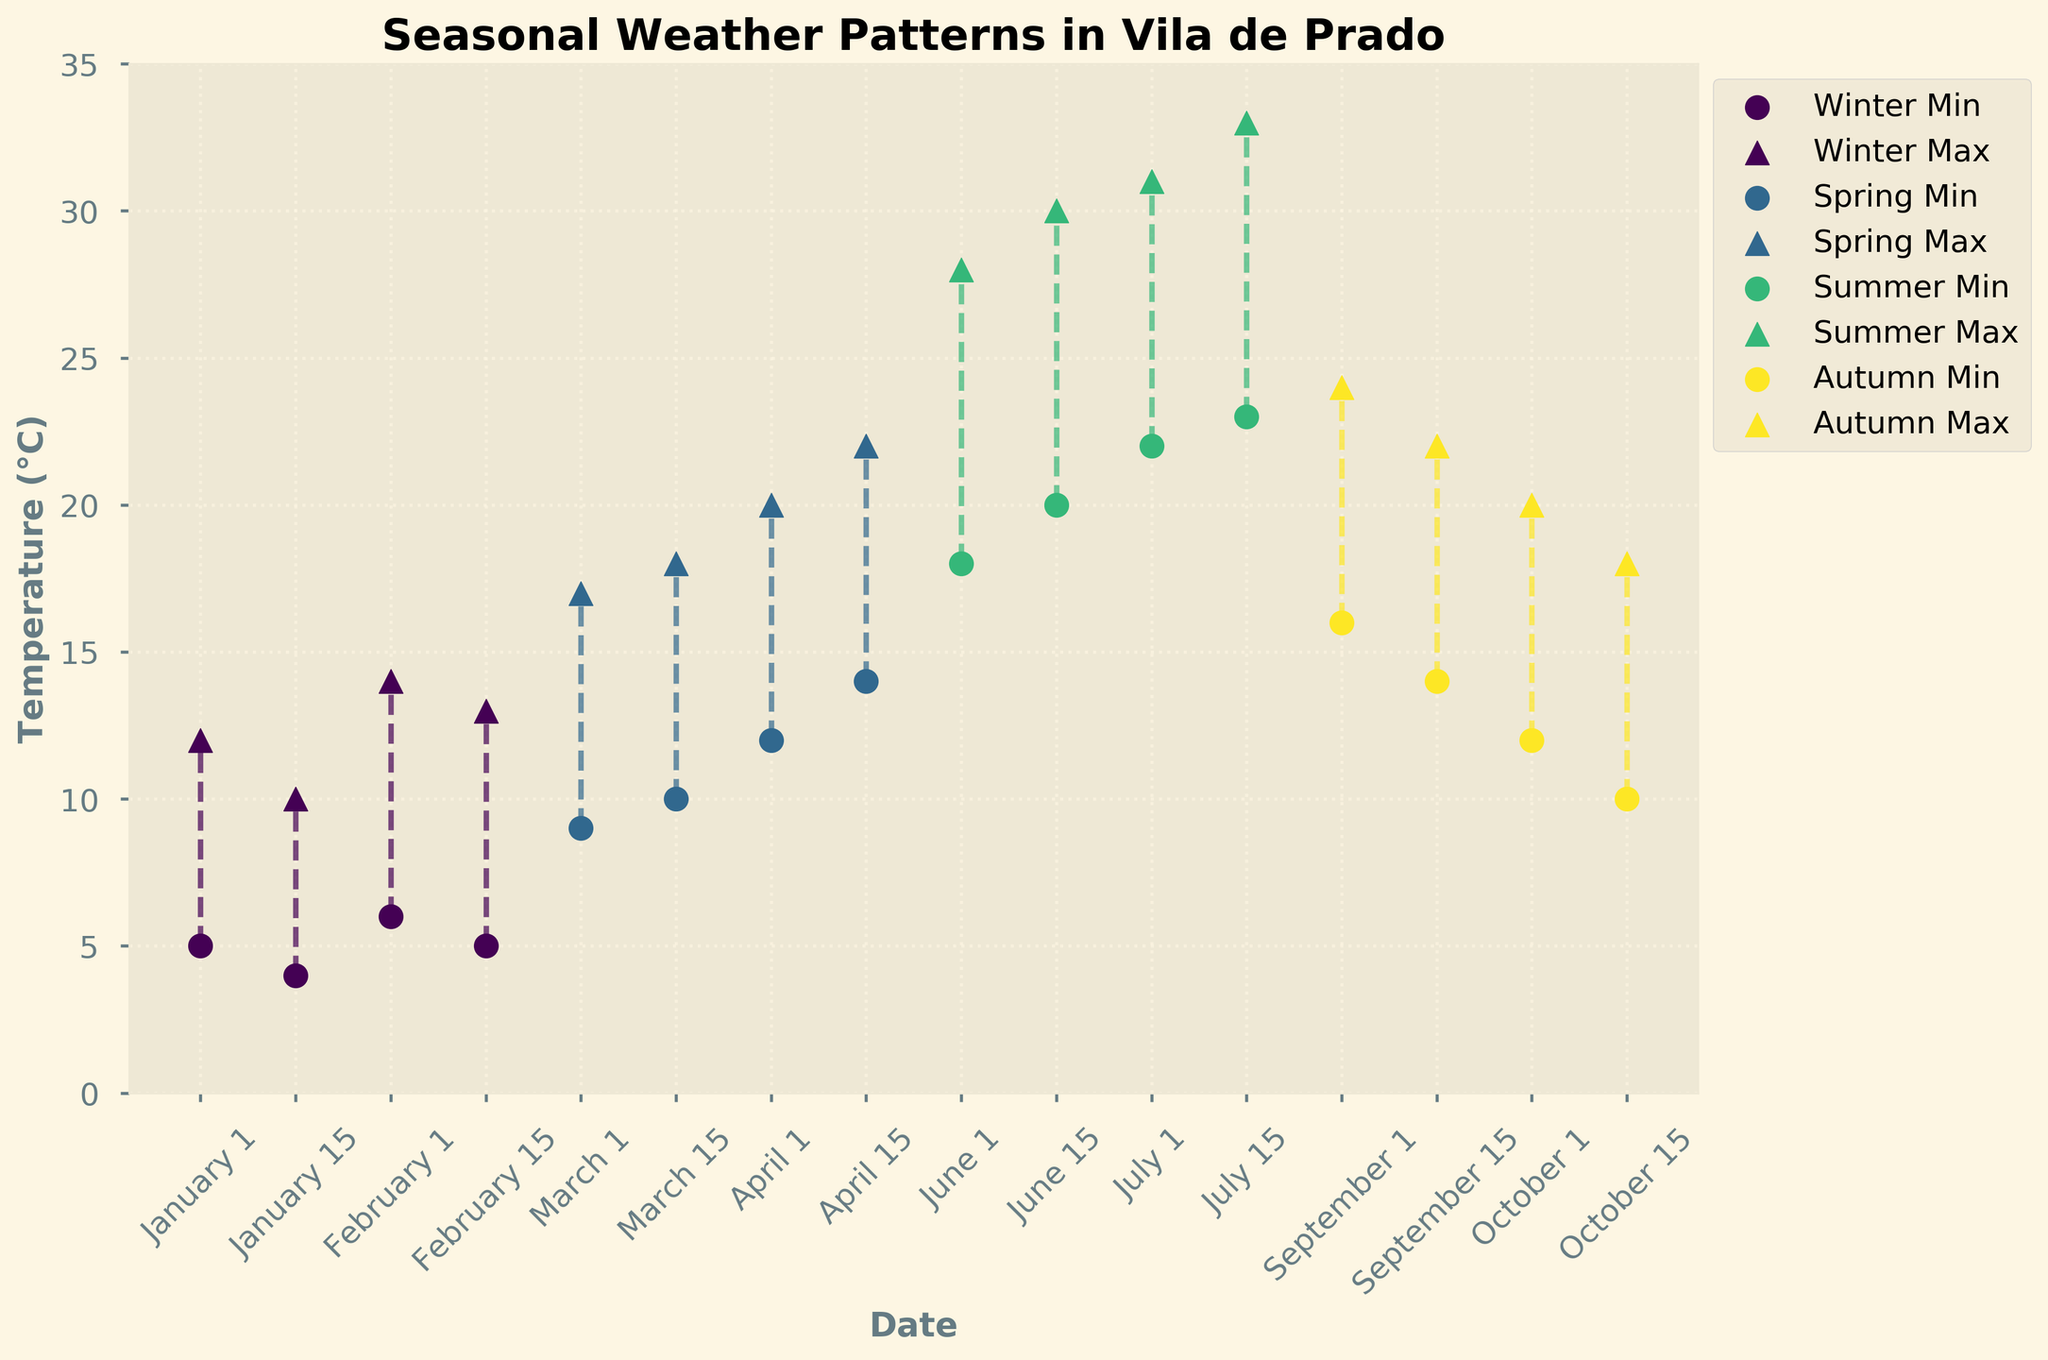What is the overall temperature range in February? Look at the min and max temperature values for February. The lowest min is 5°C, and the highest max is 14°C. The overall range is from 5°C to 14°C.
Answer: 5°C to 14°C Which season has the highest average maximum temperature? Calculate the average of maximum temperatures for each season and compare. Winter: (12+10+14+13)/4 = 12.25, Spring: (17+18+20+22)/4 = 19.25, Summer: (28+30+31+33)/4= 30.5, Autumn: (24+22+20+18)/4 = 21. For Summer, the average maximum temperature is the highest at 30.5°C.
Answer: Summer On September 1st, what is the range between the minimum and maximum temperatures? On September 1st, the min temp is 16°C and the max temp is 24°C. The range is calculated by subtracting the min temp from the max temp: 24°C - 16°C = 8°C.
Answer: 8°C How does the temperature range on June 1st compare to June 15th? On June 1st, the temperatures are 18°C (min) and 28°C (max), giving a range of 10°C. On June 15th, the temperatures are 20°C (min) and 30°C (max), giving a range of 10°C. So, both have the same temperature range.
Answer: Same Which month exhibits the greatest variation within a season? Check the difference between the highest and lowest temperatures within each season. Winter variation: max 14°C - min 4°C = 10°C, Spring variation: max 22°C - min 9°C = 13°C, Summer variation: max 33°C - min 18°C = 15°C, Autumn variation: max 24°C - min 10°C = 14°C. The greatest variation is in Summer with 15°C.
Answer: Summer What is the temperature range on March 15th? On March 15th, the temperatures are given as 10°C and 18°C. The temperature range is calculated as 18°C - 10°C = 8°C.
Answer: 8°C Which season has the narrowest overall temperature range? Compare the range for each season: Winter (4°C to 14°C) = 10°C, Spring (9°C to 22°C) = 13°C, Summer (18°C to 33°C) = 15°C, Autumn (10°C to 24°C) = 14°C. Winter has the narrowest range with 10°C.
Answer: Winter During which part of the year is the min temperature consistently above 10°C? Min temperatures above 10°C are in Spring (April 1st and 15th) and Summer (June, July). So it is consistently above 10°C from April 1st onwards until the end of Summer.
Answer: April to July 